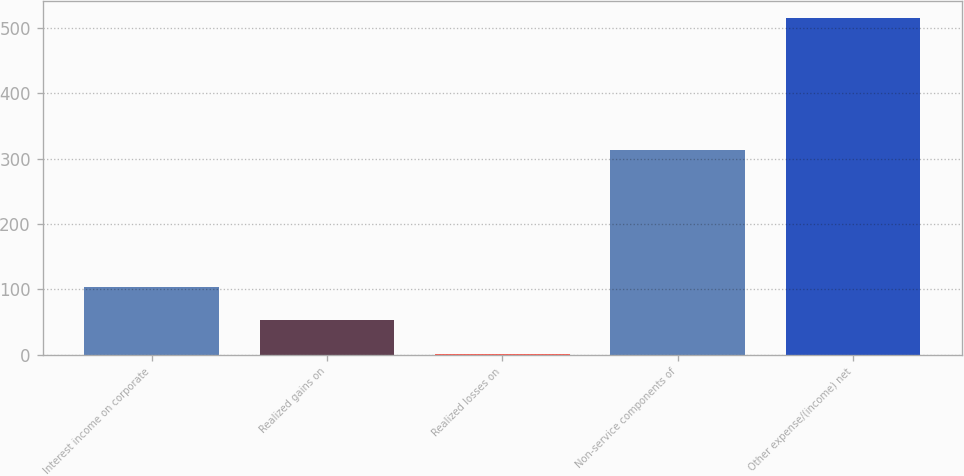<chart> <loc_0><loc_0><loc_500><loc_500><bar_chart><fcel>Interest income on corporate<fcel>Realized gains on<fcel>Realized losses on<fcel>Non-service components of<fcel>Other expense/(income) net<nl><fcel>104.18<fcel>52.79<fcel>1.4<fcel>312.7<fcel>515.3<nl></chart> 